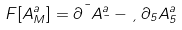Convert formula to latex. <formula><loc_0><loc_0><loc_500><loc_500>F [ A ^ { a } _ { M } ] = \partial ^ { \mu } A ^ { a } _ { \mu } - \xi \, \partial _ { 5 } A ^ { a } _ { 5 }</formula> 